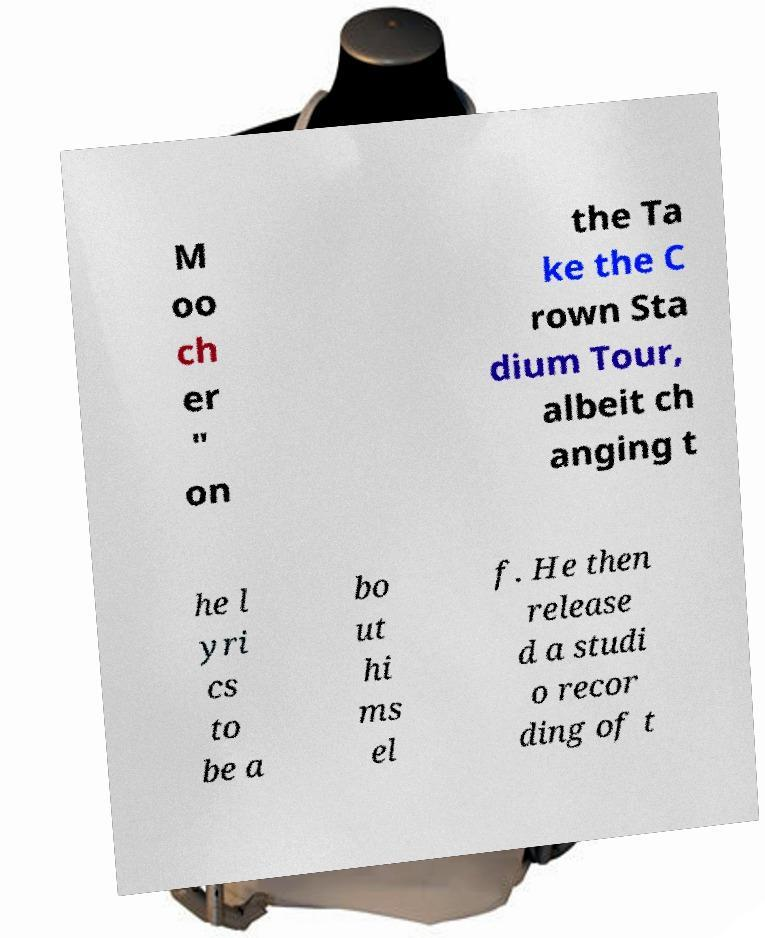What messages or text are displayed in this image? I need them in a readable, typed format. M oo ch er " on the Ta ke the C rown Sta dium Tour, albeit ch anging t he l yri cs to be a bo ut hi ms el f. He then release d a studi o recor ding of t 